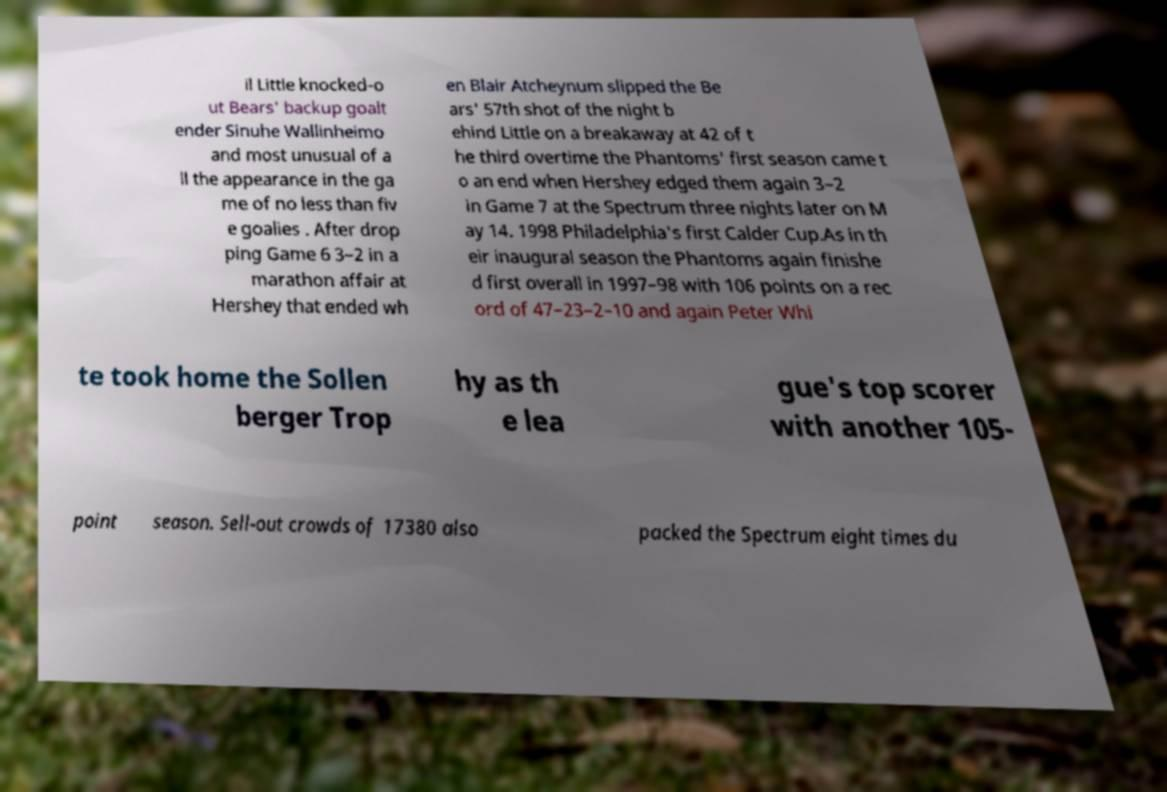Can you accurately transcribe the text from the provided image for me? il Little knocked-o ut Bears' backup goalt ender Sinuhe Wallinheimo and most unusual of a ll the appearance in the ga me of no less than fiv e goalies . After drop ping Game 6 3–2 in a marathon affair at Hershey that ended wh en Blair Atcheynum slipped the Be ars' 57th shot of the night b ehind Little on a breakaway at 42 of t he third overtime the Phantoms' first season came t o an end when Hershey edged them again 3–2 in Game 7 at the Spectrum three nights later on M ay 14. 1998 Philadelphia's first Calder Cup.As in th eir inaugural season the Phantoms again finishe d first overall in 1997–98 with 106 points on a rec ord of 47–23–2–10 and again Peter Whi te took home the Sollen berger Trop hy as th e lea gue's top scorer with another 105- point season. Sell-out crowds of 17380 also packed the Spectrum eight times du 